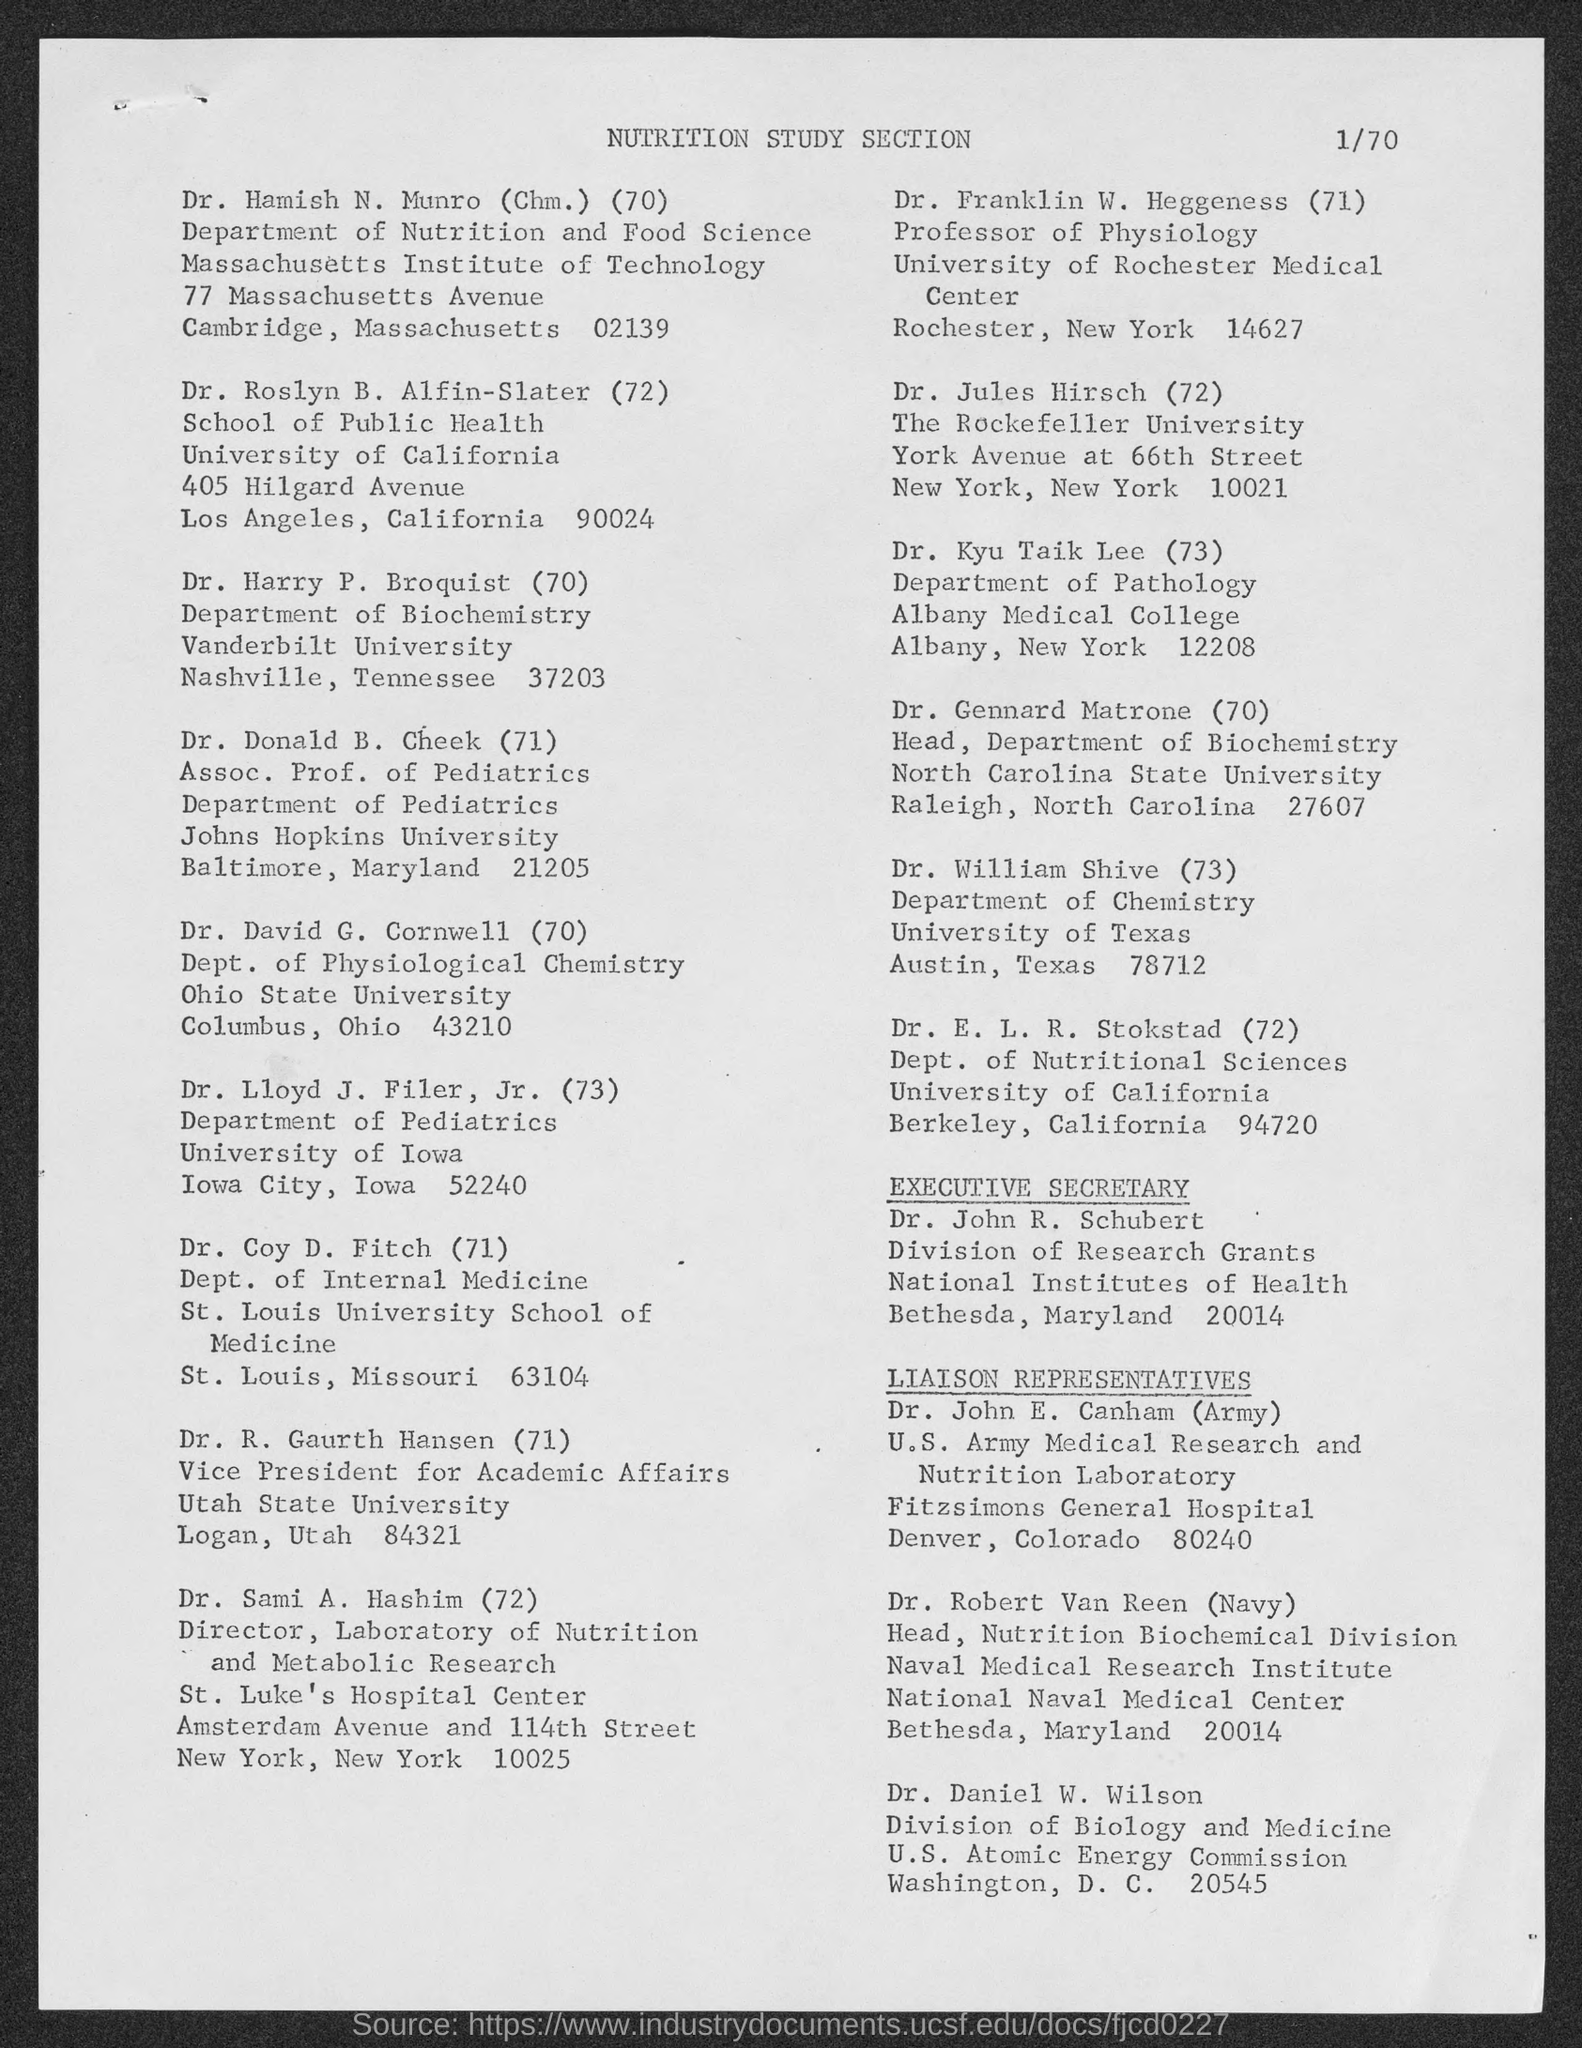Draw attention to some important aspects in this diagram. Dr. Hamish N. Munro is affiliated with the Department of Nutrition and Food Science. Dr. Kyu Taik Lee received his medical degree from Albany Medical College. The executive secretary is Dr. John R. Schubert. 